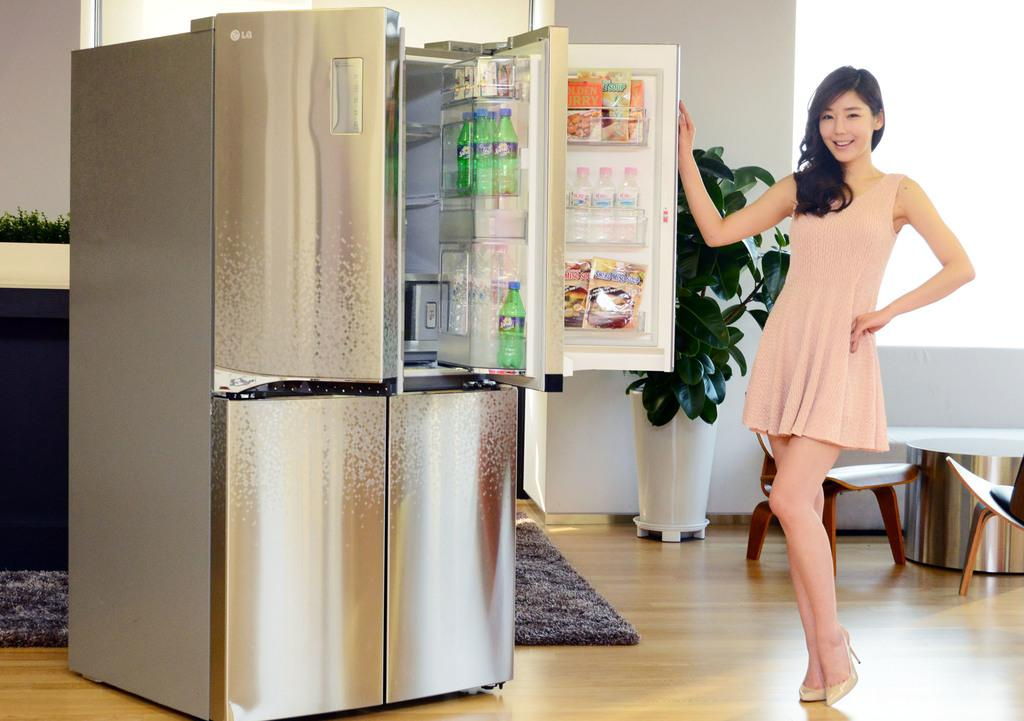Provide a one-sentence caption for the provided image. A girl opening a fridge showing products like Sprite. 